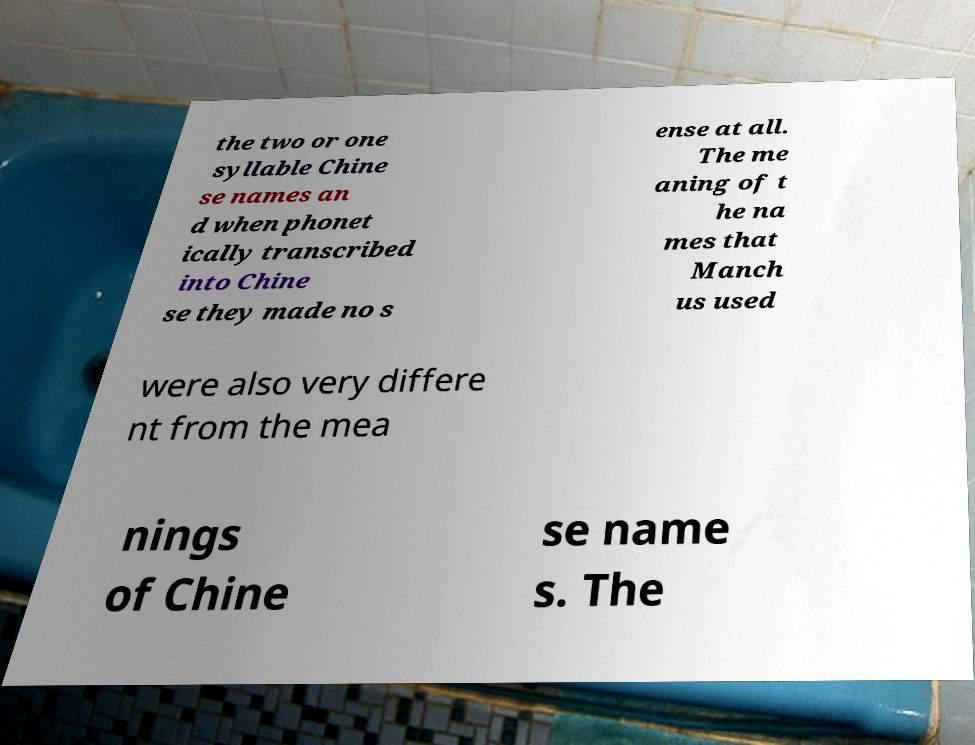Please read and relay the text visible in this image. What does it say? the two or one syllable Chine se names an d when phonet ically transcribed into Chine se they made no s ense at all. The me aning of t he na mes that Manch us used were also very differe nt from the mea nings of Chine se name s. The 